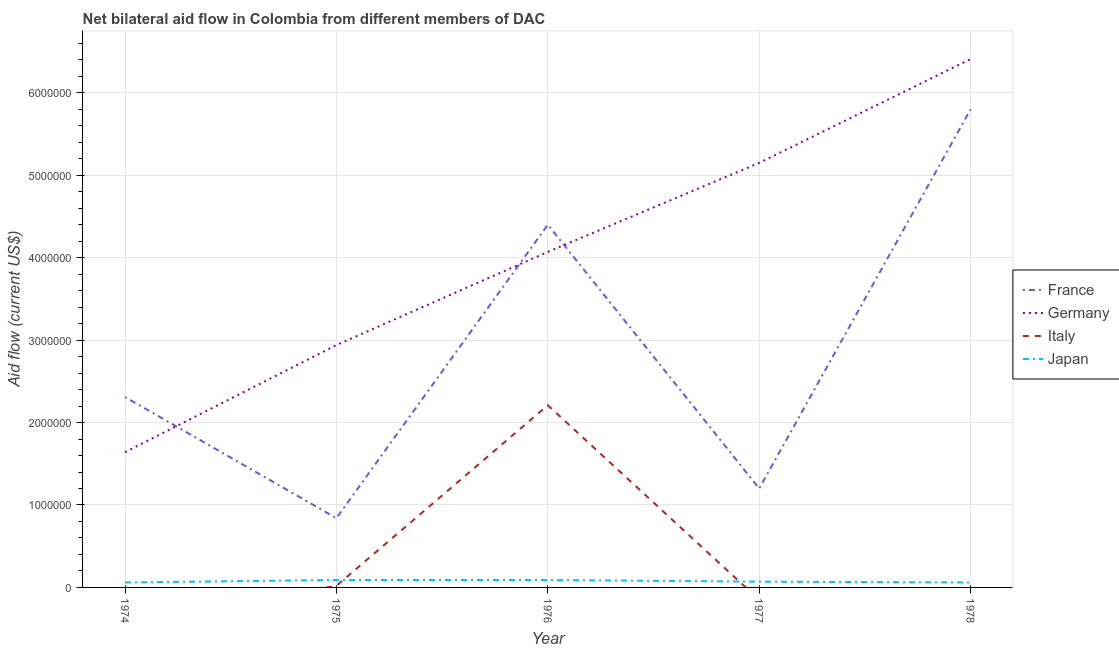What is the amount of aid given by germany in 1978?
Offer a terse response. 6.41e+06. Across all years, what is the maximum amount of aid given by france?
Ensure brevity in your answer.  5.80e+06. Across all years, what is the minimum amount of aid given by france?
Your answer should be very brief. 8.40e+05. In which year was the amount of aid given by france maximum?
Your answer should be compact. 1978. What is the total amount of aid given by france in the graph?
Your response must be concise. 1.46e+07. What is the difference between the amount of aid given by japan in 1974 and that in 1978?
Provide a succinct answer. 0. What is the difference between the amount of aid given by germany in 1975 and the amount of aid given by france in 1977?
Ensure brevity in your answer.  1.74e+06. What is the average amount of aid given by germany per year?
Offer a terse response. 4.04e+06. In the year 1976, what is the difference between the amount of aid given by france and amount of aid given by japan?
Make the answer very short. 4.31e+06. In how many years, is the amount of aid given by germany greater than 200000 US$?
Keep it short and to the point. 5. What is the ratio of the amount of aid given by japan in 1974 to that in 1975?
Provide a short and direct response. 0.67. Is the difference between the amount of aid given by japan in 1974 and 1978 greater than the difference between the amount of aid given by germany in 1974 and 1978?
Offer a very short reply. Yes. What is the difference between the highest and the second highest amount of aid given by france?
Your answer should be compact. 1.40e+06. What is the difference between the highest and the lowest amount of aid given by germany?
Provide a succinct answer. 4.77e+06. Is the sum of the amount of aid given by japan in 1974 and 1977 greater than the maximum amount of aid given by italy across all years?
Ensure brevity in your answer.  No. Is it the case that in every year, the sum of the amount of aid given by france and amount of aid given by germany is greater than the amount of aid given by italy?
Provide a short and direct response. Yes. Does the amount of aid given by japan monotonically increase over the years?
Your answer should be compact. No. Is the amount of aid given by italy strictly less than the amount of aid given by france over the years?
Provide a short and direct response. Yes. How many lines are there?
Provide a succinct answer. 4. How many years are there in the graph?
Ensure brevity in your answer.  5. What is the difference between two consecutive major ticks on the Y-axis?
Make the answer very short. 1.00e+06. Are the values on the major ticks of Y-axis written in scientific E-notation?
Your answer should be compact. No. Does the graph contain any zero values?
Offer a terse response. Yes. Does the graph contain grids?
Your answer should be very brief. Yes. Where does the legend appear in the graph?
Keep it short and to the point. Center right. How many legend labels are there?
Keep it short and to the point. 4. How are the legend labels stacked?
Offer a very short reply. Vertical. What is the title of the graph?
Your response must be concise. Net bilateral aid flow in Colombia from different members of DAC. Does "Social equity" appear as one of the legend labels in the graph?
Ensure brevity in your answer.  No. What is the Aid flow (current US$) of France in 1974?
Ensure brevity in your answer.  2.31e+06. What is the Aid flow (current US$) of Germany in 1974?
Give a very brief answer. 1.64e+06. What is the Aid flow (current US$) of Italy in 1974?
Ensure brevity in your answer.  0. What is the Aid flow (current US$) of France in 1975?
Your response must be concise. 8.40e+05. What is the Aid flow (current US$) in Germany in 1975?
Your answer should be very brief. 2.94e+06. What is the Aid flow (current US$) of Japan in 1975?
Ensure brevity in your answer.  9.00e+04. What is the Aid flow (current US$) in France in 1976?
Offer a very short reply. 4.40e+06. What is the Aid flow (current US$) in Germany in 1976?
Make the answer very short. 4.07e+06. What is the Aid flow (current US$) in Italy in 1976?
Provide a short and direct response. 2.21e+06. What is the Aid flow (current US$) of Japan in 1976?
Provide a short and direct response. 9.00e+04. What is the Aid flow (current US$) in France in 1977?
Your answer should be very brief. 1.20e+06. What is the Aid flow (current US$) in Germany in 1977?
Your answer should be compact. 5.15e+06. What is the Aid flow (current US$) in Italy in 1977?
Your response must be concise. 0. What is the Aid flow (current US$) of France in 1978?
Provide a short and direct response. 5.80e+06. What is the Aid flow (current US$) of Germany in 1978?
Provide a succinct answer. 6.41e+06. What is the Aid flow (current US$) in Japan in 1978?
Keep it short and to the point. 6.00e+04. Across all years, what is the maximum Aid flow (current US$) of France?
Make the answer very short. 5.80e+06. Across all years, what is the maximum Aid flow (current US$) in Germany?
Ensure brevity in your answer.  6.41e+06. Across all years, what is the maximum Aid flow (current US$) of Italy?
Provide a short and direct response. 2.21e+06. Across all years, what is the maximum Aid flow (current US$) in Japan?
Your answer should be very brief. 9.00e+04. Across all years, what is the minimum Aid flow (current US$) of France?
Provide a succinct answer. 8.40e+05. Across all years, what is the minimum Aid flow (current US$) in Germany?
Offer a terse response. 1.64e+06. What is the total Aid flow (current US$) in France in the graph?
Your response must be concise. 1.46e+07. What is the total Aid flow (current US$) of Germany in the graph?
Offer a very short reply. 2.02e+07. What is the total Aid flow (current US$) in Italy in the graph?
Keep it short and to the point. 2.23e+06. What is the difference between the Aid flow (current US$) in France in 1974 and that in 1975?
Your answer should be very brief. 1.47e+06. What is the difference between the Aid flow (current US$) in Germany in 1974 and that in 1975?
Keep it short and to the point. -1.30e+06. What is the difference between the Aid flow (current US$) of France in 1974 and that in 1976?
Give a very brief answer. -2.09e+06. What is the difference between the Aid flow (current US$) in Germany in 1974 and that in 1976?
Make the answer very short. -2.43e+06. What is the difference between the Aid flow (current US$) in France in 1974 and that in 1977?
Make the answer very short. 1.11e+06. What is the difference between the Aid flow (current US$) in Germany in 1974 and that in 1977?
Your answer should be very brief. -3.51e+06. What is the difference between the Aid flow (current US$) of France in 1974 and that in 1978?
Make the answer very short. -3.49e+06. What is the difference between the Aid flow (current US$) of Germany in 1974 and that in 1978?
Ensure brevity in your answer.  -4.77e+06. What is the difference between the Aid flow (current US$) of France in 1975 and that in 1976?
Your answer should be very brief. -3.56e+06. What is the difference between the Aid flow (current US$) in Germany in 1975 and that in 1976?
Keep it short and to the point. -1.13e+06. What is the difference between the Aid flow (current US$) of Italy in 1975 and that in 1976?
Keep it short and to the point. -2.19e+06. What is the difference between the Aid flow (current US$) in Japan in 1975 and that in 1976?
Keep it short and to the point. 0. What is the difference between the Aid flow (current US$) in France in 1975 and that in 1977?
Give a very brief answer. -3.60e+05. What is the difference between the Aid flow (current US$) in Germany in 1975 and that in 1977?
Ensure brevity in your answer.  -2.21e+06. What is the difference between the Aid flow (current US$) in Japan in 1975 and that in 1977?
Keep it short and to the point. 2.00e+04. What is the difference between the Aid flow (current US$) of France in 1975 and that in 1978?
Provide a succinct answer. -4.96e+06. What is the difference between the Aid flow (current US$) of Germany in 1975 and that in 1978?
Give a very brief answer. -3.47e+06. What is the difference between the Aid flow (current US$) in France in 1976 and that in 1977?
Provide a short and direct response. 3.20e+06. What is the difference between the Aid flow (current US$) in Germany in 1976 and that in 1977?
Offer a very short reply. -1.08e+06. What is the difference between the Aid flow (current US$) in Japan in 1976 and that in 1977?
Offer a terse response. 2.00e+04. What is the difference between the Aid flow (current US$) in France in 1976 and that in 1978?
Give a very brief answer. -1.40e+06. What is the difference between the Aid flow (current US$) in Germany in 1976 and that in 1978?
Ensure brevity in your answer.  -2.34e+06. What is the difference between the Aid flow (current US$) of France in 1977 and that in 1978?
Make the answer very short. -4.60e+06. What is the difference between the Aid flow (current US$) of Germany in 1977 and that in 1978?
Your answer should be compact. -1.26e+06. What is the difference between the Aid flow (current US$) in Japan in 1977 and that in 1978?
Your response must be concise. 10000. What is the difference between the Aid flow (current US$) in France in 1974 and the Aid flow (current US$) in Germany in 1975?
Your answer should be compact. -6.30e+05. What is the difference between the Aid flow (current US$) in France in 1974 and the Aid flow (current US$) in Italy in 1975?
Offer a terse response. 2.29e+06. What is the difference between the Aid flow (current US$) in France in 1974 and the Aid flow (current US$) in Japan in 1975?
Provide a succinct answer. 2.22e+06. What is the difference between the Aid flow (current US$) of Germany in 1974 and the Aid flow (current US$) of Italy in 1975?
Offer a very short reply. 1.62e+06. What is the difference between the Aid flow (current US$) of Germany in 1974 and the Aid flow (current US$) of Japan in 1975?
Keep it short and to the point. 1.55e+06. What is the difference between the Aid flow (current US$) in France in 1974 and the Aid flow (current US$) in Germany in 1976?
Ensure brevity in your answer.  -1.76e+06. What is the difference between the Aid flow (current US$) in France in 1974 and the Aid flow (current US$) in Italy in 1976?
Offer a very short reply. 1.00e+05. What is the difference between the Aid flow (current US$) of France in 1974 and the Aid flow (current US$) of Japan in 1976?
Offer a very short reply. 2.22e+06. What is the difference between the Aid flow (current US$) of Germany in 1974 and the Aid flow (current US$) of Italy in 1976?
Give a very brief answer. -5.70e+05. What is the difference between the Aid flow (current US$) of Germany in 1974 and the Aid flow (current US$) of Japan in 1976?
Your answer should be compact. 1.55e+06. What is the difference between the Aid flow (current US$) in France in 1974 and the Aid flow (current US$) in Germany in 1977?
Ensure brevity in your answer.  -2.84e+06. What is the difference between the Aid flow (current US$) in France in 1974 and the Aid flow (current US$) in Japan in 1977?
Your response must be concise. 2.24e+06. What is the difference between the Aid flow (current US$) in Germany in 1974 and the Aid flow (current US$) in Japan in 1977?
Offer a terse response. 1.57e+06. What is the difference between the Aid flow (current US$) of France in 1974 and the Aid flow (current US$) of Germany in 1978?
Your answer should be very brief. -4.10e+06. What is the difference between the Aid flow (current US$) of France in 1974 and the Aid flow (current US$) of Japan in 1978?
Offer a very short reply. 2.25e+06. What is the difference between the Aid flow (current US$) in Germany in 1974 and the Aid flow (current US$) in Japan in 1978?
Provide a short and direct response. 1.58e+06. What is the difference between the Aid flow (current US$) of France in 1975 and the Aid flow (current US$) of Germany in 1976?
Offer a terse response. -3.23e+06. What is the difference between the Aid flow (current US$) of France in 1975 and the Aid flow (current US$) of Italy in 1976?
Provide a short and direct response. -1.37e+06. What is the difference between the Aid flow (current US$) of France in 1975 and the Aid flow (current US$) of Japan in 1976?
Offer a terse response. 7.50e+05. What is the difference between the Aid flow (current US$) in Germany in 1975 and the Aid flow (current US$) in Italy in 1976?
Keep it short and to the point. 7.30e+05. What is the difference between the Aid flow (current US$) of Germany in 1975 and the Aid flow (current US$) of Japan in 1976?
Ensure brevity in your answer.  2.85e+06. What is the difference between the Aid flow (current US$) of Italy in 1975 and the Aid flow (current US$) of Japan in 1976?
Provide a succinct answer. -7.00e+04. What is the difference between the Aid flow (current US$) of France in 1975 and the Aid flow (current US$) of Germany in 1977?
Provide a short and direct response. -4.31e+06. What is the difference between the Aid flow (current US$) of France in 1975 and the Aid flow (current US$) of Japan in 1977?
Ensure brevity in your answer.  7.70e+05. What is the difference between the Aid flow (current US$) of Germany in 1975 and the Aid flow (current US$) of Japan in 1977?
Provide a short and direct response. 2.87e+06. What is the difference between the Aid flow (current US$) in Italy in 1975 and the Aid flow (current US$) in Japan in 1977?
Keep it short and to the point. -5.00e+04. What is the difference between the Aid flow (current US$) in France in 1975 and the Aid flow (current US$) in Germany in 1978?
Provide a short and direct response. -5.57e+06. What is the difference between the Aid flow (current US$) in France in 1975 and the Aid flow (current US$) in Japan in 1978?
Make the answer very short. 7.80e+05. What is the difference between the Aid flow (current US$) in Germany in 1975 and the Aid flow (current US$) in Japan in 1978?
Your response must be concise. 2.88e+06. What is the difference between the Aid flow (current US$) in France in 1976 and the Aid flow (current US$) in Germany in 1977?
Your answer should be very brief. -7.50e+05. What is the difference between the Aid flow (current US$) of France in 1976 and the Aid flow (current US$) of Japan in 1977?
Your answer should be very brief. 4.33e+06. What is the difference between the Aid flow (current US$) of Germany in 1976 and the Aid flow (current US$) of Japan in 1977?
Your response must be concise. 4.00e+06. What is the difference between the Aid flow (current US$) in Italy in 1976 and the Aid flow (current US$) in Japan in 1977?
Offer a terse response. 2.14e+06. What is the difference between the Aid flow (current US$) of France in 1976 and the Aid flow (current US$) of Germany in 1978?
Your answer should be very brief. -2.01e+06. What is the difference between the Aid flow (current US$) in France in 1976 and the Aid flow (current US$) in Japan in 1978?
Your answer should be compact. 4.34e+06. What is the difference between the Aid flow (current US$) in Germany in 1976 and the Aid flow (current US$) in Japan in 1978?
Keep it short and to the point. 4.01e+06. What is the difference between the Aid flow (current US$) of Italy in 1976 and the Aid flow (current US$) of Japan in 1978?
Your response must be concise. 2.15e+06. What is the difference between the Aid flow (current US$) in France in 1977 and the Aid flow (current US$) in Germany in 1978?
Ensure brevity in your answer.  -5.21e+06. What is the difference between the Aid flow (current US$) in France in 1977 and the Aid flow (current US$) in Japan in 1978?
Offer a terse response. 1.14e+06. What is the difference between the Aid flow (current US$) in Germany in 1977 and the Aid flow (current US$) in Japan in 1978?
Give a very brief answer. 5.09e+06. What is the average Aid flow (current US$) in France per year?
Your answer should be very brief. 2.91e+06. What is the average Aid flow (current US$) in Germany per year?
Make the answer very short. 4.04e+06. What is the average Aid flow (current US$) of Italy per year?
Keep it short and to the point. 4.46e+05. What is the average Aid flow (current US$) in Japan per year?
Your answer should be very brief. 7.40e+04. In the year 1974, what is the difference between the Aid flow (current US$) of France and Aid flow (current US$) of Germany?
Your response must be concise. 6.70e+05. In the year 1974, what is the difference between the Aid flow (current US$) in France and Aid flow (current US$) in Japan?
Ensure brevity in your answer.  2.25e+06. In the year 1974, what is the difference between the Aid flow (current US$) of Germany and Aid flow (current US$) of Japan?
Give a very brief answer. 1.58e+06. In the year 1975, what is the difference between the Aid flow (current US$) of France and Aid flow (current US$) of Germany?
Your answer should be very brief. -2.10e+06. In the year 1975, what is the difference between the Aid flow (current US$) in France and Aid flow (current US$) in Italy?
Provide a succinct answer. 8.20e+05. In the year 1975, what is the difference between the Aid flow (current US$) of France and Aid flow (current US$) of Japan?
Ensure brevity in your answer.  7.50e+05. In the year 1975, what is the difference between the Aid flow (current US$) in Germany and Aid flow (current US$) in Italy?
Your answer should be very brief. 2.92e+06. In the year 1975, what is the difference between the Aid flow (current US$) in Germany and Aid flow (current US$) in Japan?
Ensure brevity in your answer.  2.85e+06. In the year 1975, what is the difference between the Aid flow (current US$) of Italy and Aid flow (current US$) of Japan?
Ensure brevity in your answer.  -7.00e+04. In the year 1976, what is the difference between the Aid flow (current US$) in France and Aid flow (current US$) in Germany?
Offer a terse response. 3.30e+05. In the year 1976, what is the difference between the Aid flow (current US$) in France and Aid flow (current US$) in Italy?
Provide a short and direct response. 2.19e+06. In the year 1976, what is the difference between the Aid flow (current US$) in France and Aid flow (current US$) in Japan?
Provide a short and direct response. 4.31e+06. In the year 1976, what is the difference between the Aid flow (current US$) of Germany and Aid flow (current US$) of Italy?
Your answer should be compact. 1.86e+06. In the year 1976, what is the difference between the Aid flow (current US$) in Germany and Aid flow (current US$) in Japan?
Provide a succinct answer. 3.98e+06. In the year 1976, what is the difference between the Aid flow (current US$) in Italy and Aid flow (current US$) in Japan?
Provide a succinct answer. 2.12e+06. In the year 1977, what is the difference between the Aid flow (current US$) in France and Aid flow (current US$) in Germany?
Your answer should be compact. -3.95e+06. In the year 1977, what is the difference between the Aid flow (current US$) in France and Aid flow (current US$) in Japan?
Provide a short and direct response. 1.13e+06. In the year 1977, what is the difference between the Aid flow (current US$) in Germany and Aid flow (current US$) in Japan?
Your response must be concise. 5.08e+06. In the year 1978, what is the difference between the Aid flow (current US$) in France and Aid flow (current US$) in Germany?
Keep it short and to the point. -6.10e+05. In the year 1978, what is the difference between the Aid flow (current US$) of France and Aid flow (current US$) of Japan?
Provide a short and direct response. 5.74e+06. In the year 1978, what is the difference between the Aid flow (current US$) of Germany and Aid flow (current US$) of Japan?
Your answer should be compact. 6.35e+06. What is the ratio of the Aid flow (current US$) in France in 1974 to that in 1975?
Your answer should be very brief. 2.75. What is the ratio of the Aid flow (current US$) in Germany in 1974 to that in 1975?
Your response must be concise. 0.56. What is the ratio of the Aid flow (current US$) in Japan in 1974 to that in 1975?
Your answer should be very brief. 0.67. What is the ratio of the Aid flow (current US$) of France in 1974 to that in 1976?
Your answer should be compact. 0.53. What is the ratio of the Aid flow (current US$) of Germany in 1974 to that in 1976?
Your answer should be very brief. 0.4. What is the ratio of the Aid flow (current US$) in Japan in 1974 to that in 1976?
Your response must be concise. 0.67. What is the ratio of the Aid flow (current US$) in France in 1974 to that in 1977?
Offer a very short reply. 1.93. What is the ratio of the Aid flow (current US$) in Germany in 1974 to that in 1977?
Offer a terse response. 0.32. What is the ratio of the Aid flow (current US$) of France in 1974 to that in 1978?
Give a very brief answer. 0.4. What is the ratio of the Aid flow (current US$) of Germany in 1974 to that in 1978?
Ensure brevity in your answer.  0.26. What is the ratio of the Aid flow (current US$) of Japan in 1974 to that in 1978?
Your answer should be compact. 1. What is the ratio of the Aid flow (current US$) in France in 1975 to that in 1976?
Provide a succinct answer. 0.19. What is the ratio of the Aid flow (current US$) in Germany in 1975 to that in 1976?
Give a very brief answer. 0.72. What is the ratio of the Aid flow (current US$) in Italy in 1975 to that in 1976?
Offer a terse response. 0.01. What is the ratio of the Aid flow (current US$) of France in 1975 to that in 1977?
Make the answer very short. 0.7. What is the ratio of the Aid flow (current US$) of Germany in 1975 to that in 1977?
Give a very brief answer. 0.57. What is the ratio of the Aid flow (current US$) in Japan in 1975 to that in 1977?
Keep it short and to the point. 1.29. What is the ratio of the Aid flow (current US$) in France in 1975 to that in 1978?
Provide a succinct answer. 0.14. What is the ratio of the Aid flow (current US$) of Germany in 1975 to that in 1978?
Offer a terse response. 0.46. What is the ratio of the Aid flow (current US$) in France in 1976 to that in 1977?
Make the answer very short. 3.67. What is the ratio of the Aid flow (current US$) of Germany in 1976 to that in 1977?
Give a very brief answer. 0.79. What is the ratio of the Aid flow (current US$) in Japan in 1976 to that in 1977?
Offer a very short reply. 1.29. What is the ratio of the Aid flow (current US$) in France in 1976 to that in 1978?
Offer a very short reply. 0.76. What is the ratio of the Aid flow (current US$) in Germany in 1976 to that in 1978?
Offer a very short reply. 0.63. What is the ratio of the Aid flow (current US$) in France in 1977 to that in 1978?
Your answer should be compact. 0.21. What is the ratio of the Aid flow (current US$) of Germany in 1977 to that in 1978?
Ensure brevity in your answer.  0.8. What is the difference between the highest and the second highest Aid flow (current US$) of France?
Your response must be concise. 1.40e+06. What is the difference between the highest and the second highest Aid flow (current US$) of Germany?
Offer a terse response. 1.26e+06. What is the difference between the highest and the lowest Aid flow (current US$) in France?
Ensure brevity in your answer.  4.96e+06. What is the difference between the highest and the lowest Aid flow (current US$) of Germany?
Your answer should be compact. 4.77e+06. What is the difference between the highest and the lowest Aid flow (current US$) in Italy?
Make the answer very short. 2.21e+06. What is the difference between the highest and the lowest Aid flow (current US$) in Japan?
Your response must be concise. 3.00e+04. 